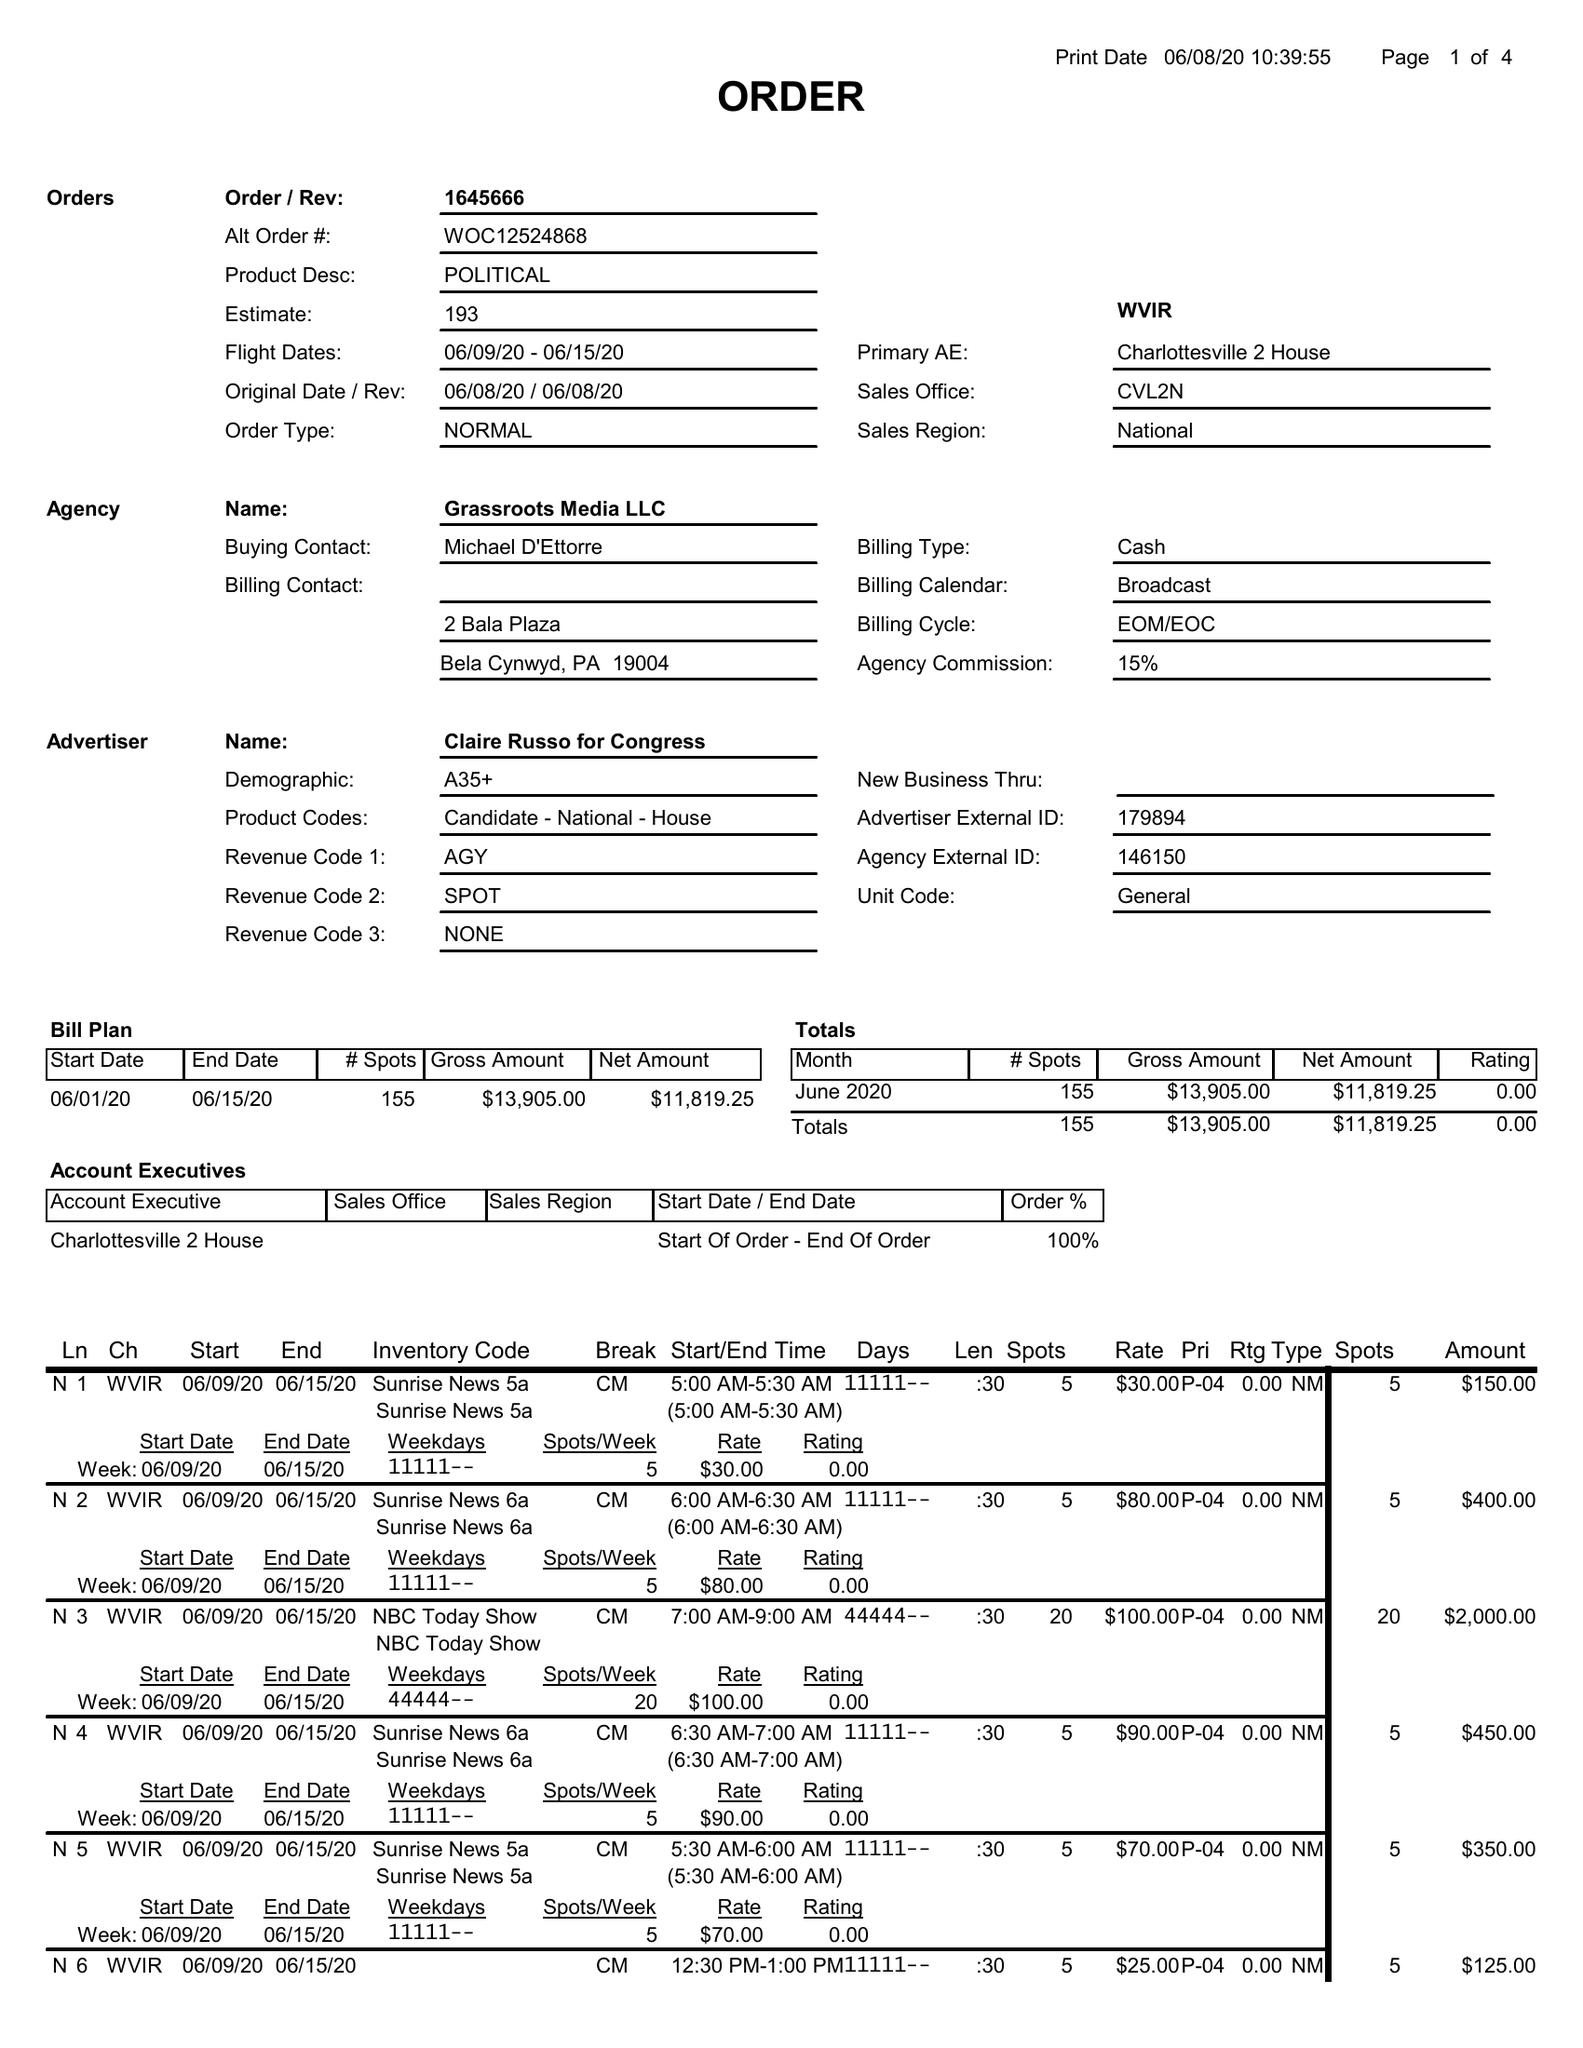What is the value for the advertiser?
Answer the question using a single word or phrase. CLAIRE RUSSO FOR CONGRESS 